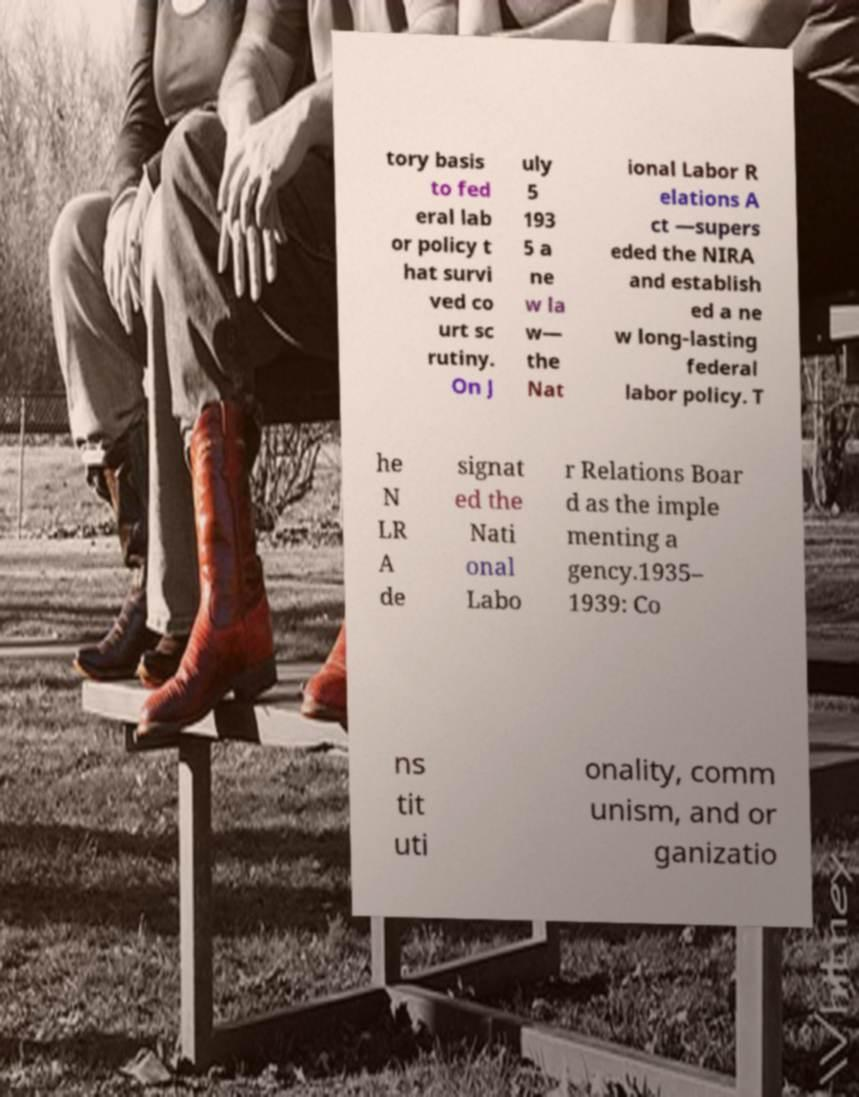Please read and relay the text visible in this image. What does it say? tory basis to fed eral lab or policy t hat survi ved co urt sc rutiny. On J uly 5 193 5 a ne w la w— the Nat ional Labor R elations A ct —supers eded the NIRA and establish ed a ne w long-lasting federal labor policy. T he N LR A de signat ed the Nati onal Labo r Relations Boar d as the imple menting a gency.1935– 1939: Co ns tit uti onality, comm unism, and or ganizatio 